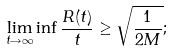<formula> <loc_0><loc_0><loc_500><loc_500>\underset { t \rightarrow \infty } { \lim } \inf \frac { R ( t ) } { t } \geq \sqrt { \frac { 1 } { 2 M } } ;</formula> 